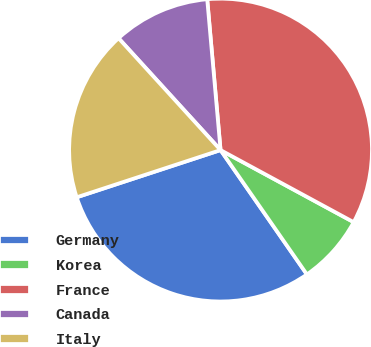Convert chart to OTSL. <chart><loc_0><loc_0><loc_500><loc_500><pie_chart><fcel>Germany<fcel>Korea<fcel>France<fcel>Canada<fcel>Italy<nl><fcel>29.61%<fcel>7.44%<fcel>34.3%<fcel>10.36%<fcel>18.28%<nl></chart> 